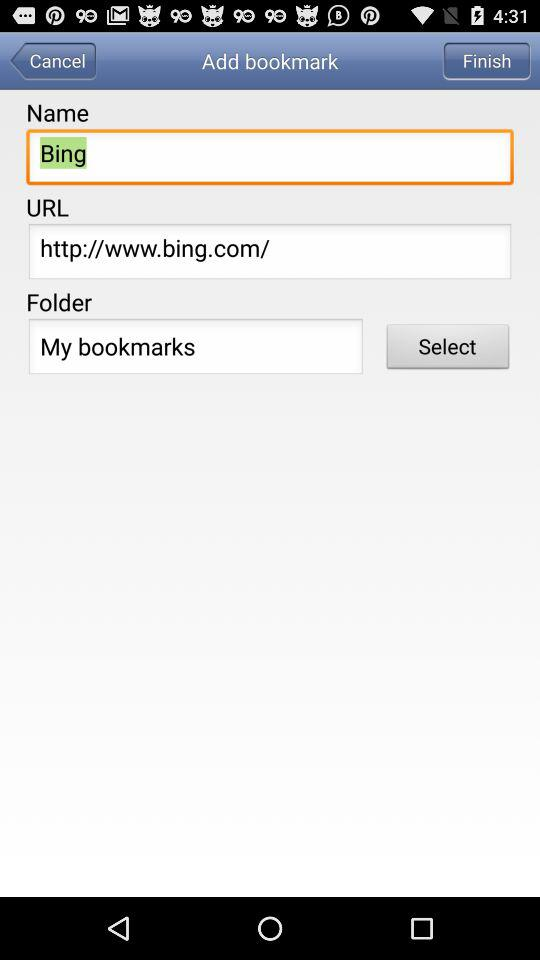What is the name given? The name is "Bing". 